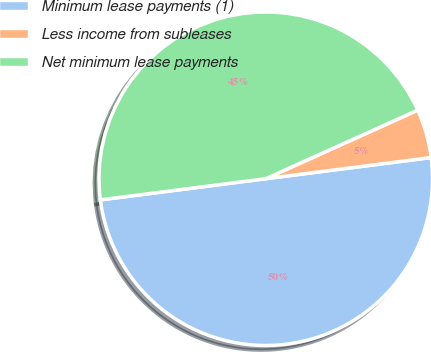Convert chart. <chart><loc_0><loc_0><loc_500><loc_500><pie_chart><fcel>Minimum lease payments (1)<fcel>Less income from subleases<fcel>Net minimum lease payments<nl><fcel>50.0%<fcel>4.72%<fcel>45.28%<nl></chart> 